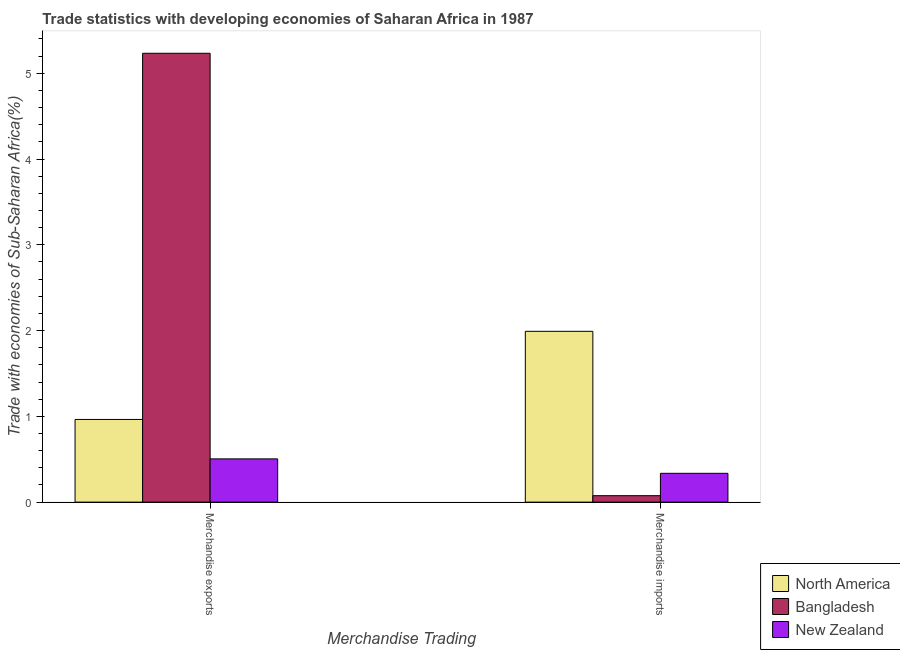How many different coloured bars are there?
Your answer should be very brief. 3. Are the number of bars per tick equal to the number of legend labels?
Your response must be concise. Yes. How many bars are there on the 2nd tick from the left?
Your answer should be very brief. 3. What is the merchandise imports in Bangladesh?
Provide a succinct answer. 0.08. Across all countries, what is the maximum merchandise imports?
Your answer should be compact. 1.99. Across all countries, what is the minimum merchandise imports?
Provide a short and direct response. 0.08. In which country was the merchandise exports maximum?
Give a very brief answer. Bangladesh. What is the total merchandise imports in the graph?
Provide a succinct answer. 2.4. What is the difference between the merchandise imports in North America and that in New Zealand?
Your answer should be very brief. 1.66. What is the difference between the merchandise exports in Bangladesh and the merchandise imports in New Zealand?
Offer a terse response. 4.9. What is the average merchandise exports per country?
Keep it short and to the point. 2.23. What is the difference between the merchandise exports and merchandise imports in North America?
Offer a terse response. -1.03. What is the ratio of the merchandise exports in North America to that in Bangladesh?
Offer a terse response. 0.18. Is the merchandise exports in New Zealand less than that in North America?
Your answer should be very brief. Yes. In how many countries, is the merchandise exports greater than the average merchandise exports taken over all countries?
Your answer should be compact. 1. What does the 2nd bar from the left in Merchandise exports represents?
Offer a terse response. Bangladesh. What does the 1st bar from the right in Merchandise imports represents?
Provide a short and direct response. New Zealand. How many bars are there?
Your response must be concise. 6. Are the values on the major ticks of Y-axis written in scientific E-notation?
Keep it short and to the point. No. Does the graph contain any zero values?
Provide a succinct answer. No. How are the legend labels stacked?
Your answer should be compact. Vertical. What is the title of the graph?
Ensure brevity in your answer.  Trade statistics with developing economies of Saharan Africa in 1987. Does "Virgin Islands" appear as one of the legend labels in the graph?
Provide a short and direct response. No. What is the label or title of the X-axis?
Ensure brevity in your answer.  Merchandise Trading. What is the label or title of the Y-axis?
Ensure brevity in your answer.  Trade with economies of Sub-Saharan Africa(%). What is the Trade with economies of Sub-Saharan Africa(%) in North America in Merchandise exports?
Offer a terse response. 0.96. What is the Trade with economies of Sub-Saharan Africa(%) of Bangladesh in Merchandise exports?
Your response must be concise. 5.23. What is the Trade with economies of Sub-Saharan Africa(%) of New Zealand in Merchandise exports?
Keep it short and to the point. 0.5. What is the Trade with economies of Sub-Saharan Africa(%) in North America in Merchandise imports?
Give a very brief answer. 1.99. What is the Trade with economies of Sub-Saharan Africa(%) of Bangladesh in Merchandise imports?
Your response must be concise. 0.08. What is the Trade with economies of Sub-Saharan Africa(%) in New Zealand in Merchandise imports?
Your response must be concise. 0.34. Across all Merchandise Trading, what is the maximum Trade with economies of Sub-Saharan Africa(%) of North America?
Keep it short and to the point. 1.99. Across all Merchandise Trading, what is the maximum Trade with economies of Sub-Saharan Africa(%) in Bangladesh?
Your answer should be compact. 5.23. Across all Merchandise Trading, what is the maximum Trade with economies of Sub-Saharan Africa(%) in New Zealand?
Give a very brief answer. 0.5. Across all Merchandise Trading, what is the minimum Trade with economies of Sub-Saharan Africa(%) of North America?
Provide a succinct answer. 0.96. Across all Merchandise Trading, what is the minimum Trade with economies of Sub-Saharan Africa(%) of Bangladesh?
Provide a succinct answer. 0.08. Across all Merchandise Trading, what is the minimum Trade with economies of Sub-Saharan Africa(%) of New Zealand?
Your answer should be compact. 0.34. What is the total Trade with economies of Sub-Saharan Africa(%) of North America in the graph?
Give a very brief answer. 2.96. What is the total Trade with economies of Sub-Saharan Africa(%) in Bangladesh in the graph?
Offer a terse response. 5.31. What is the total Trade with economies of Sub-Saharan Africa(%) in New Zealand in the graph?
Ensure brevity in your answer.  0.84. What is the difference between the Trade with economies of Sub-Saharan Africa(%) of North America in Merchandise exports and that in Merchandise imports?
Give a very brief answer. -1.03. What is the difference between the Trade with economies of Sub-Saharan Africa(%) of Bangladesh in Merchandise exports and that in Merchandise imports?
Give a very brief answer. 5.16. What is the difference between the Trade with economies of Sub-Saharan Africa(%) in New Zealand in Merchandise exports and that in Merchandise imports?
Offer a terse response. 0.17. What is the difference between the Trade with economies of Sub-Saharan Africa(%) in North America in Merchandise exports and the Trade with economies of Sub-Saharan Africa(%) in Bangladesh in Merchandise imports?
Keep it short and to the point. 0.89. What is the difference between the Trade with economies of Sub-Saharan Africa(%) of North America in Merchandise exports and the Trade with economies of Sub-Saharan Africa(%) of New Zealand in Merchandise imports?
Your response must be concise. 0.63. What is the difference between the Trade with economies of Sub-Saharan Africa(%) of Bangladesh in Merchandise exports and the Trade with economies of Sub-Saharan Africa(%) of New Zealand in Merchandise imports?
Your response must be concise. 4.9. What is the average Trade with economies of Sub-Saharan Africa(%) of North America per Merchandise Trading?
Offer a very short reply. 1.48. What is the average Trade with economies of Sub-Saharan Africa(%) in Bangladesh per Merchandise Trading?
Give a very brief answer. 2.65. What is the average Trade with economies of Sub-Saharan Africa(%) in New Zealand per Merchandise Trading?
Ensure brevity in your answer.  0.42. What is the difference between the Trade with economies of Sub-Saharan Africa(%) in North America and Trade with economies of Sub-Saharan Africa(%) in Bangladesh in Merchandise exports?
Provide a short and direct response. -4.27. What is the difference between the Trade with economies of Sub-Saharan Africa(%) in North America and Trade with economies of Sub-Saharan Africa(%) in New Zealand in Merchandise exports?
Offer a very short reply. 0.46. What is the difference between the Trade with economies of Sub-Saharan Africa(%) in Bangladesh and Trade with economies of Sub-Saharan Africa(%) in New Zealand in Merchandise exports?
Offer a terse response. 4.73. What is the difference between the Trade with economies of Sub-Saharan Africa(%) in North America and Trade with economies of Sub-Saharan Africa(%) in Bangladesh in Merchandise imports?
Provide a succinct answer. 1.92. What is the difference between the Trade with economies of Sub-Saharan Africa(%) of North America and Trade with economies of Sub-Saharan Africa(%) of New Zealand in Merchandise imports?
Offer a very short reply. 1.66. What is the difference between the Trade with economies of Sub-Saharan Africa(%) of Bangladesh and Trade with economies of Sub-Saharan Africa(%) of New Zealand in Merchandise imports?
Offer a very short reply. -0.26. What is the ratio of the Trade with economies of Sub-Saharan Africa(%) of North America in Merchandise exports to that in Merchandise imports?
Provide a succinct answer. 0.48. What is the ratio of the Trade with economies of Sub-Saharan Africa(%) in Bangladesh in Merchandise exports to that in Merchandise imports?
Provide a succinct answer. 69.7. What is the ratio of the Trade with economies of Sub-Saharan Africa(%) in New Zealand in Merchandise exports to that in Merchandise imports?
Keep it short and to the point. 1.5. What is the difference between the highest and the second highest Trade with economies of Sub-Saharan Africa(%) in North America?
Your answer should be very brief. 1.03. What is the difference between the highest and the second highest Trade with economies of Sub-Saharan Africa(%) of Bangladesh?
Provide a succinct answer. 5.16. What is the difference between the highest and the second highest Trade with economies of Sub-Saharan Africa(%) in New Zealand?
Your response must be concise. 0.17. What is the difference between the highest and the lowest Trade with economies of Sub-Saharan Africa(%) in North America?
Make the answer very short. 1.03. What is the difference between the highest and the lowest Trade with economies of Sub-Saharan Africa(%) of Bangladesh?
Keep it short and to the point. 5.16. What is the difference between the highest and the lowest Trade with economies of Sub-Saharan Africa(%) of New Zealand?
Your answer should be compact. 0.17. 